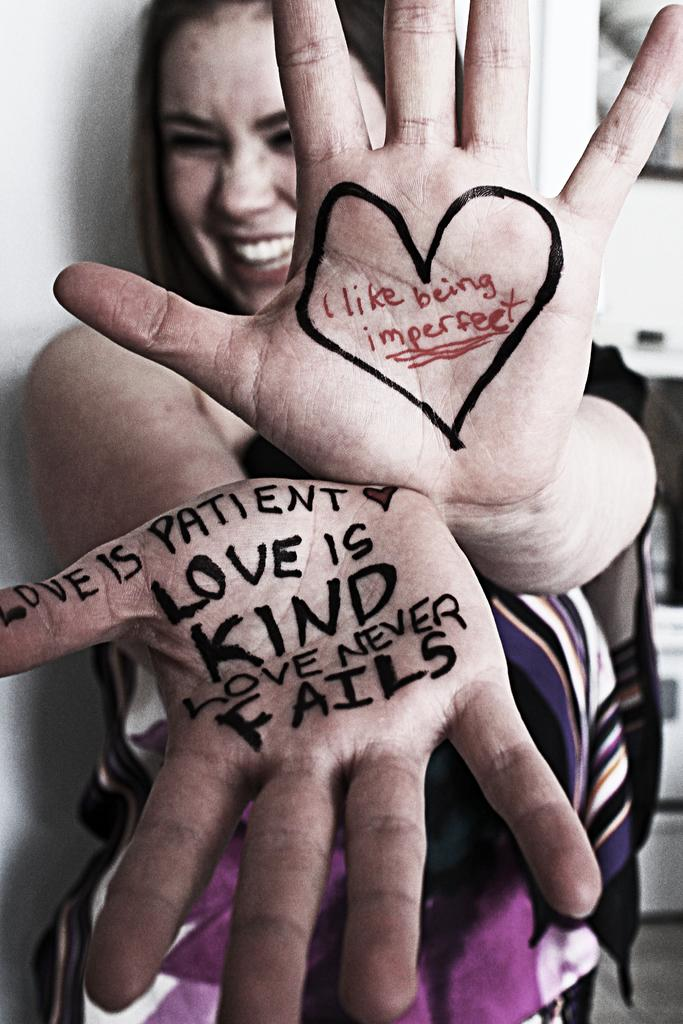Who is the main subject in the image? There is a girl in the image. Where is the girl positioned in the image? The girl is standing in the middle of the image. What is the girl doing with her hands? The girl is showing her palms. What is written or drawn on her palms? There is text on her palms. What can be seen in the background of the image? There is a wall in the background of the image. What type of animal is sitting on the girl's shoulder in the image? There is no animal present in the image; the girl is standing alone with her palms showing text. 